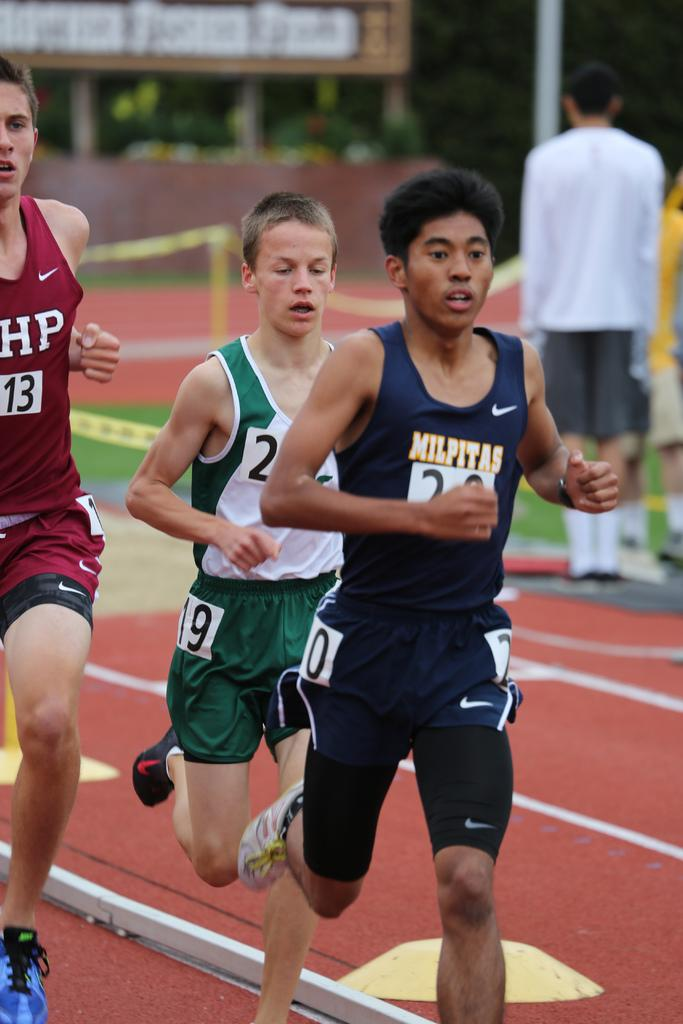What are the men in the image doing? The men in the image are running on the ground. What can be seen in the background of the image? In the background, there is caution tape, a hoarding, trees, and poles. Are there any other people present in the image? Yes, there are persons standing on the ground on the right side. What type of plastic is covering the tent in the image? There is no tent present in the image, and therefore no plastic covering it. 